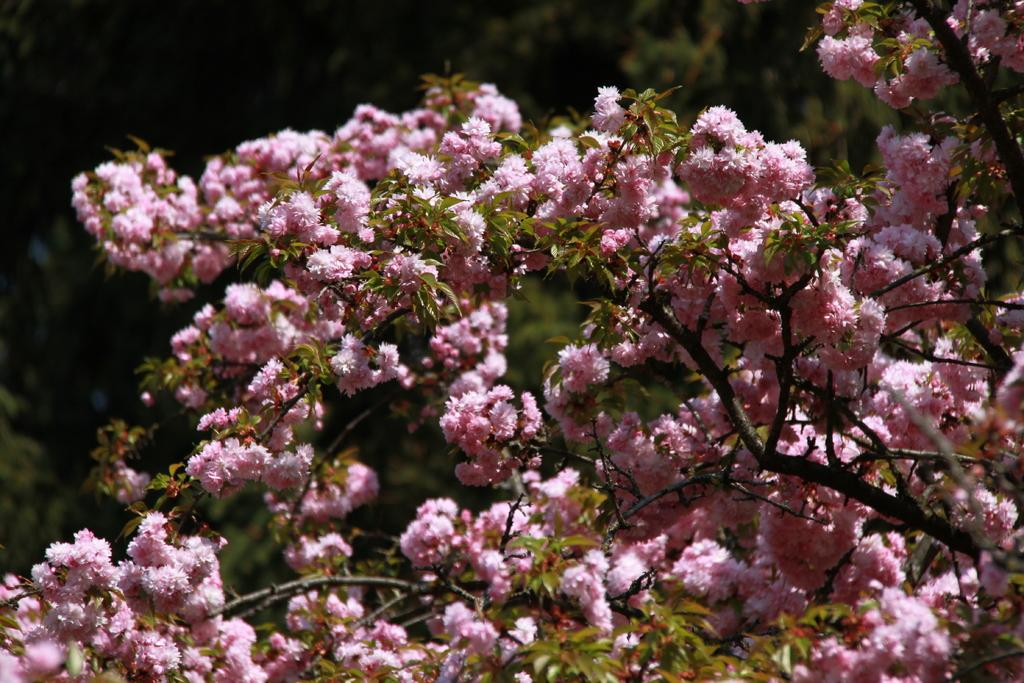What type of trees are present in the image? There are trees with flowers in the image. What color are the flowers on the trees? The flowers are pink in color. Are there any trees visible in the background of the image? Yes, there are trees in the background of the image. How is the background of the image depicted? The background of the image is blurred. What type of cushion can be seen supporting the flowers in the image? There is no cushion present in the image; the flowers are on the trees. How does the hammer contribute to the growth of the flowers in the image? There is no hammer present in the image, and it does not contribute to the growth of the flowers. 